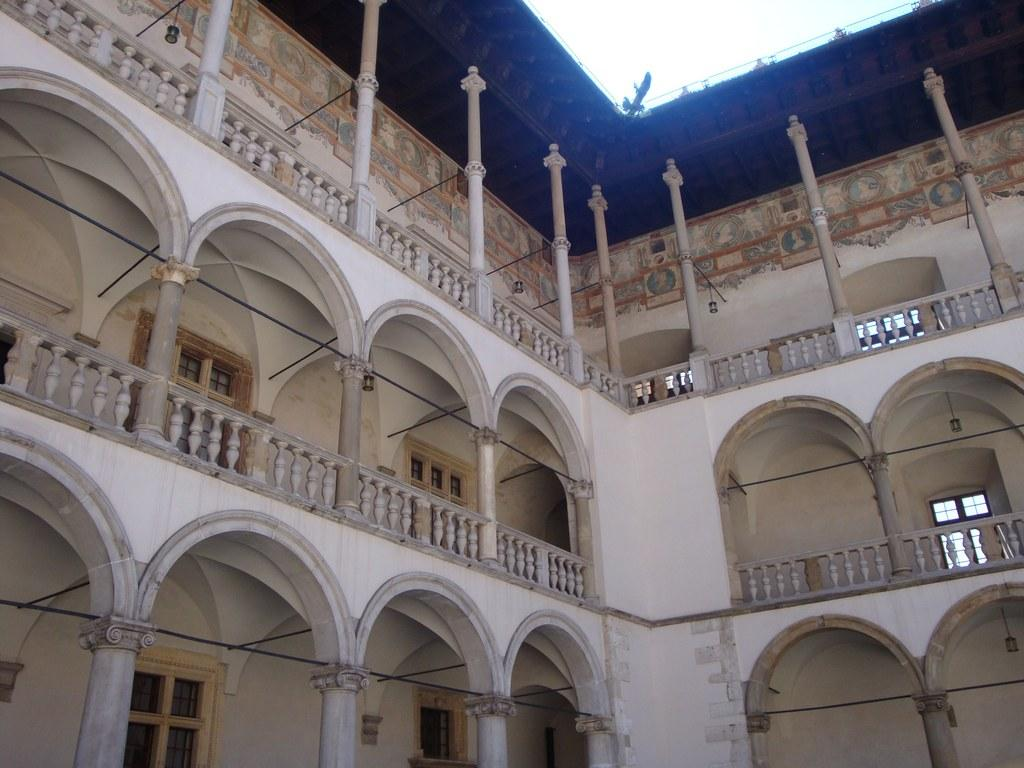What is the main structure visible in the foreground of the image? There is a building in the foreground of the image. What architectural features can be seen in the foreground of the image? There are pillars, a roof, and a wall visible in the foreground of the image. How many eggs are being used to play the game in the image? There is no game or eggs present in the image. 